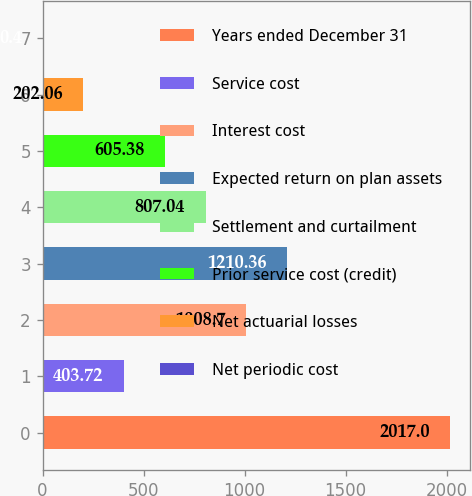Convert chart to OTSL. <chart><loc_0><loc_0><loc_500><loc_500><bar_chart><fcel>Years ended December 31<fcel>Service cost<fcel>Interest cost<fcel>Expected return on plan assets<fcel>Settlement and curtailment<fcel>Prior service cost (credit)<fcel>Net actuarial losses<fcel>Net periodic cost<nl><fcel>2017<fcel>403.72<fcel>1008.7<fcel>1210.36<fcel>807.04<fcel>605.38<fcel>202.06<fcel>0.4<nl></chart> 